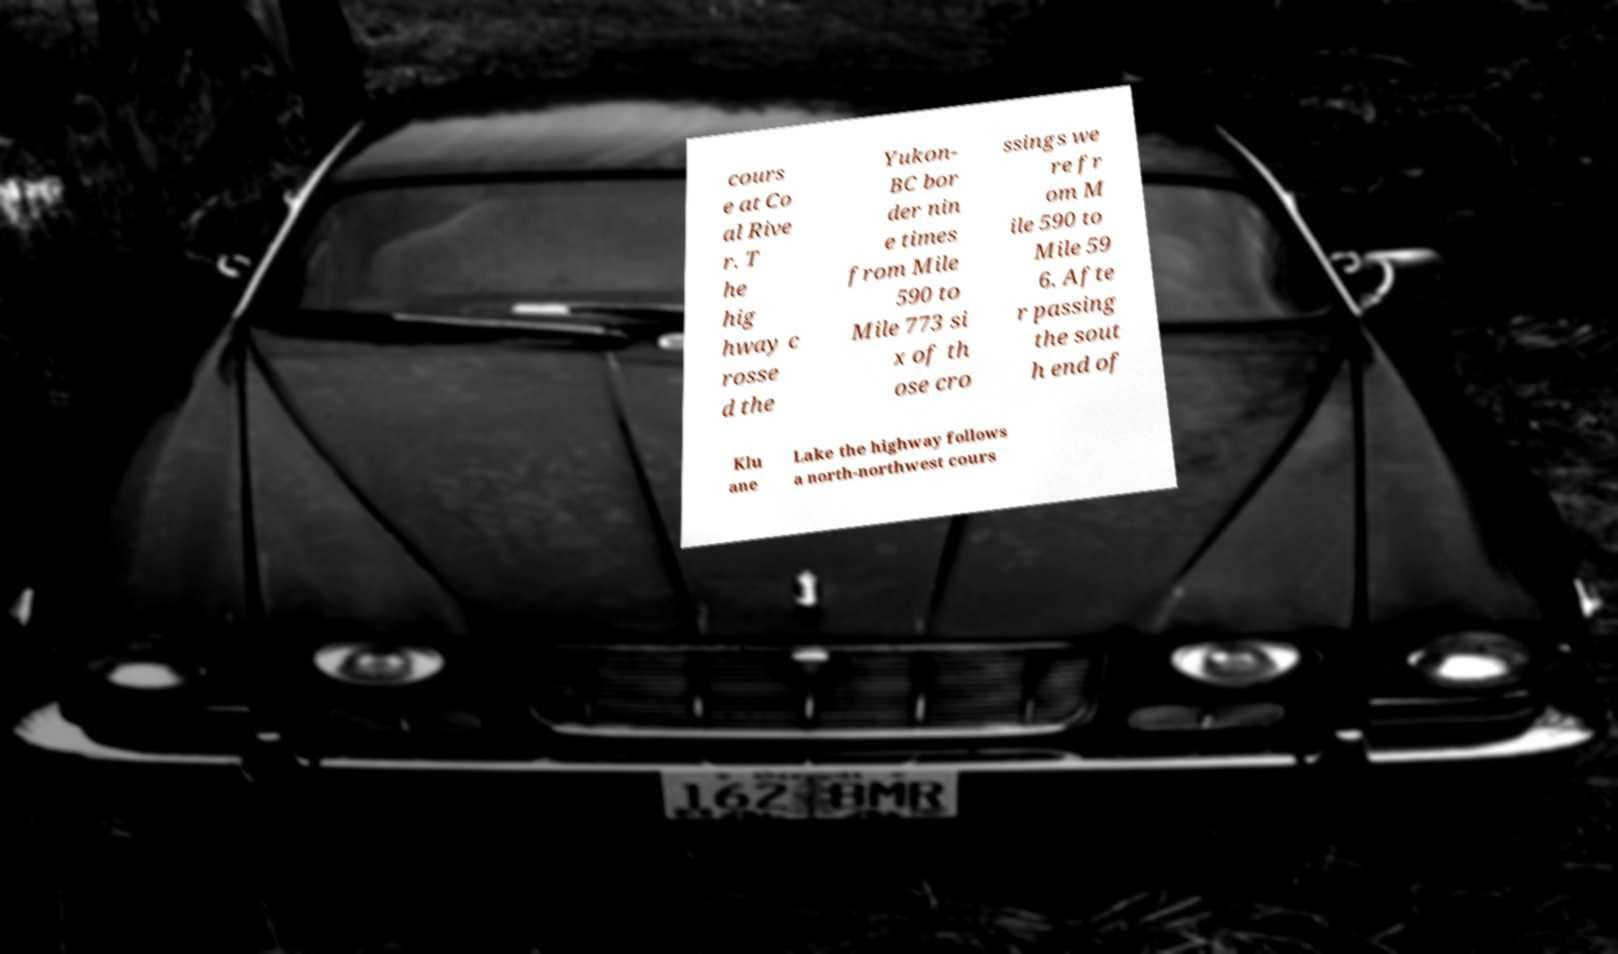Could you assist in decoding the text presented in this image and type it out clearly? cours e at Co al Rive r. T he hig hway c rosse d the Yukon- BC bor der nin e times from Mile 590 to Mile 773 si x of th ose cro ssings we re fr om M ile 590 to Mile 59 6. Afte r passing the sout h end of Klu ane Lake the highway follows a north-northwest cours 